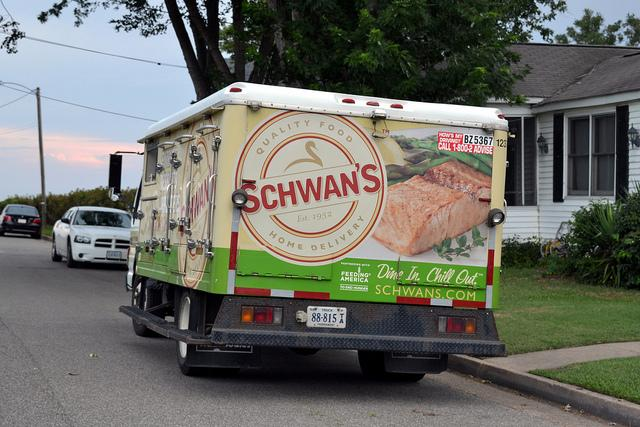How does the it feel inside the back of the truck? cold 